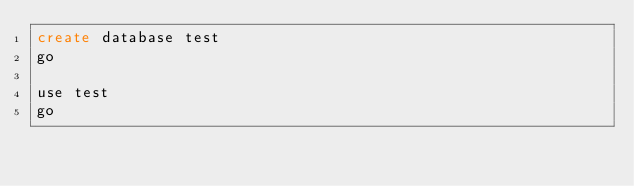Convert code to text. <code><loc_0><loc_0><loc_500><loc_500><_SQL_>create database test
go

use test
go
</code> 